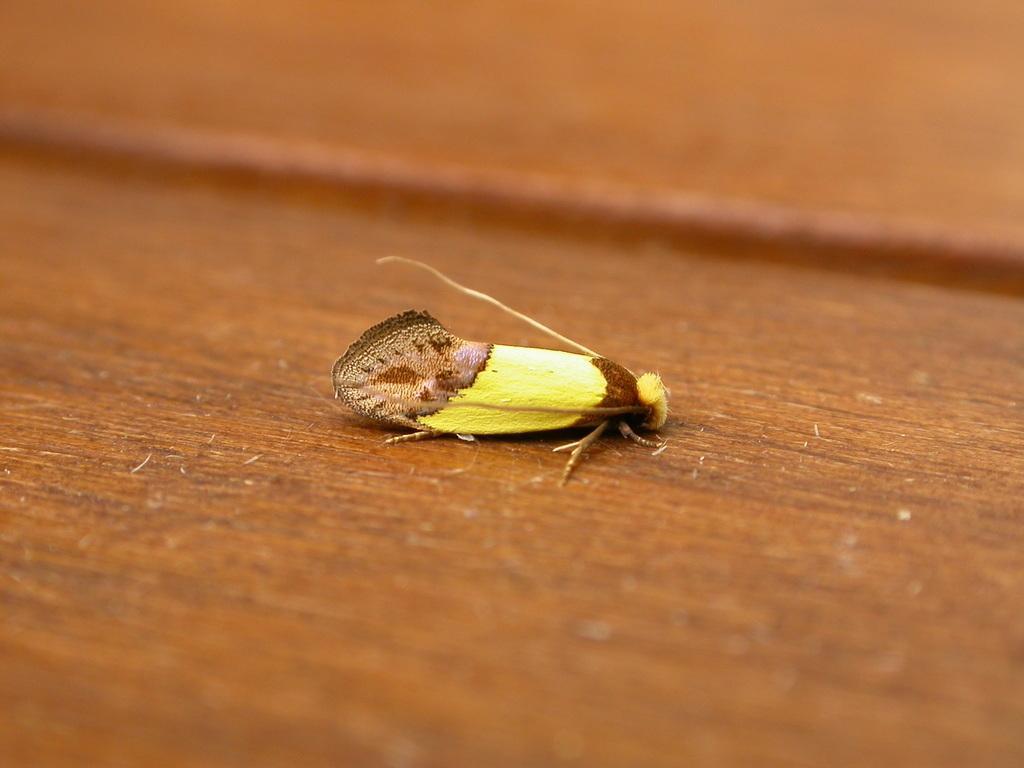Could you give a brief overview of what you see in this image? This picture contains an insect which is in yellow and brown color is on the brown carpet. In the background, it is brown in color and it is blurred in the background. 